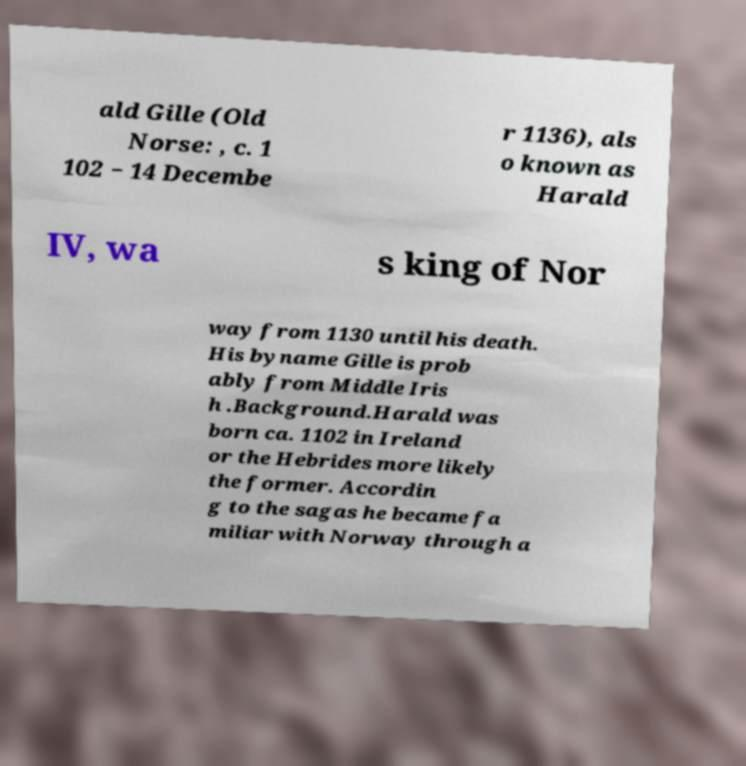I need the written content from this picture converted into text. Can you do that? ald Gille (Old Norse: , c. 1 102 − 14 Decembe r 1136), als o known as Harald IV, wa s king of Nor way from 1130 until his death. His byname Gille is prob ably from Middle Iris h .Background.Harald was born ca. 1102 in Ireland or the Hebrides more likely the former. Accordin g to the sagas he became fa miliar with Norway through a 